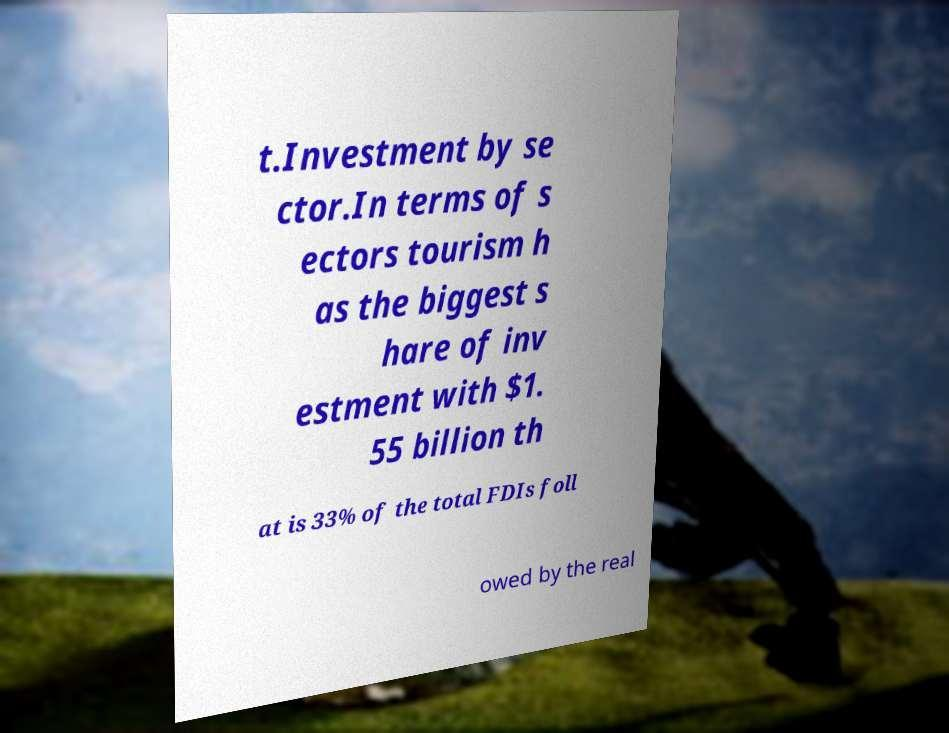Could you assist in decoding the text presented in this image and type it out clearly? t.Investment by se ctor.In terms of s ectors tourism h as the biggest s hare of inv estment with $1. 55 billion th at is 33% of the total FDIs foll owed by the real 